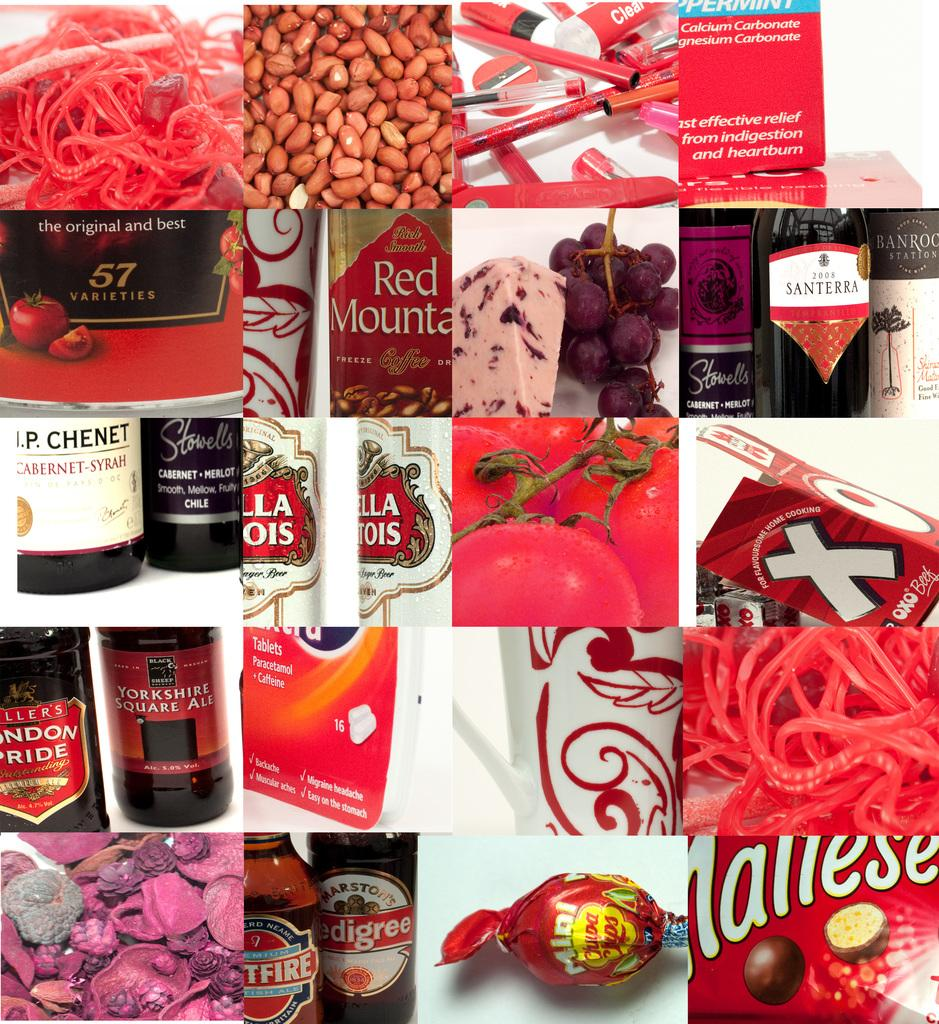<image>
Relay a brief, clear account of the picture shown. A collage of red items includes a Red Mountain label. 